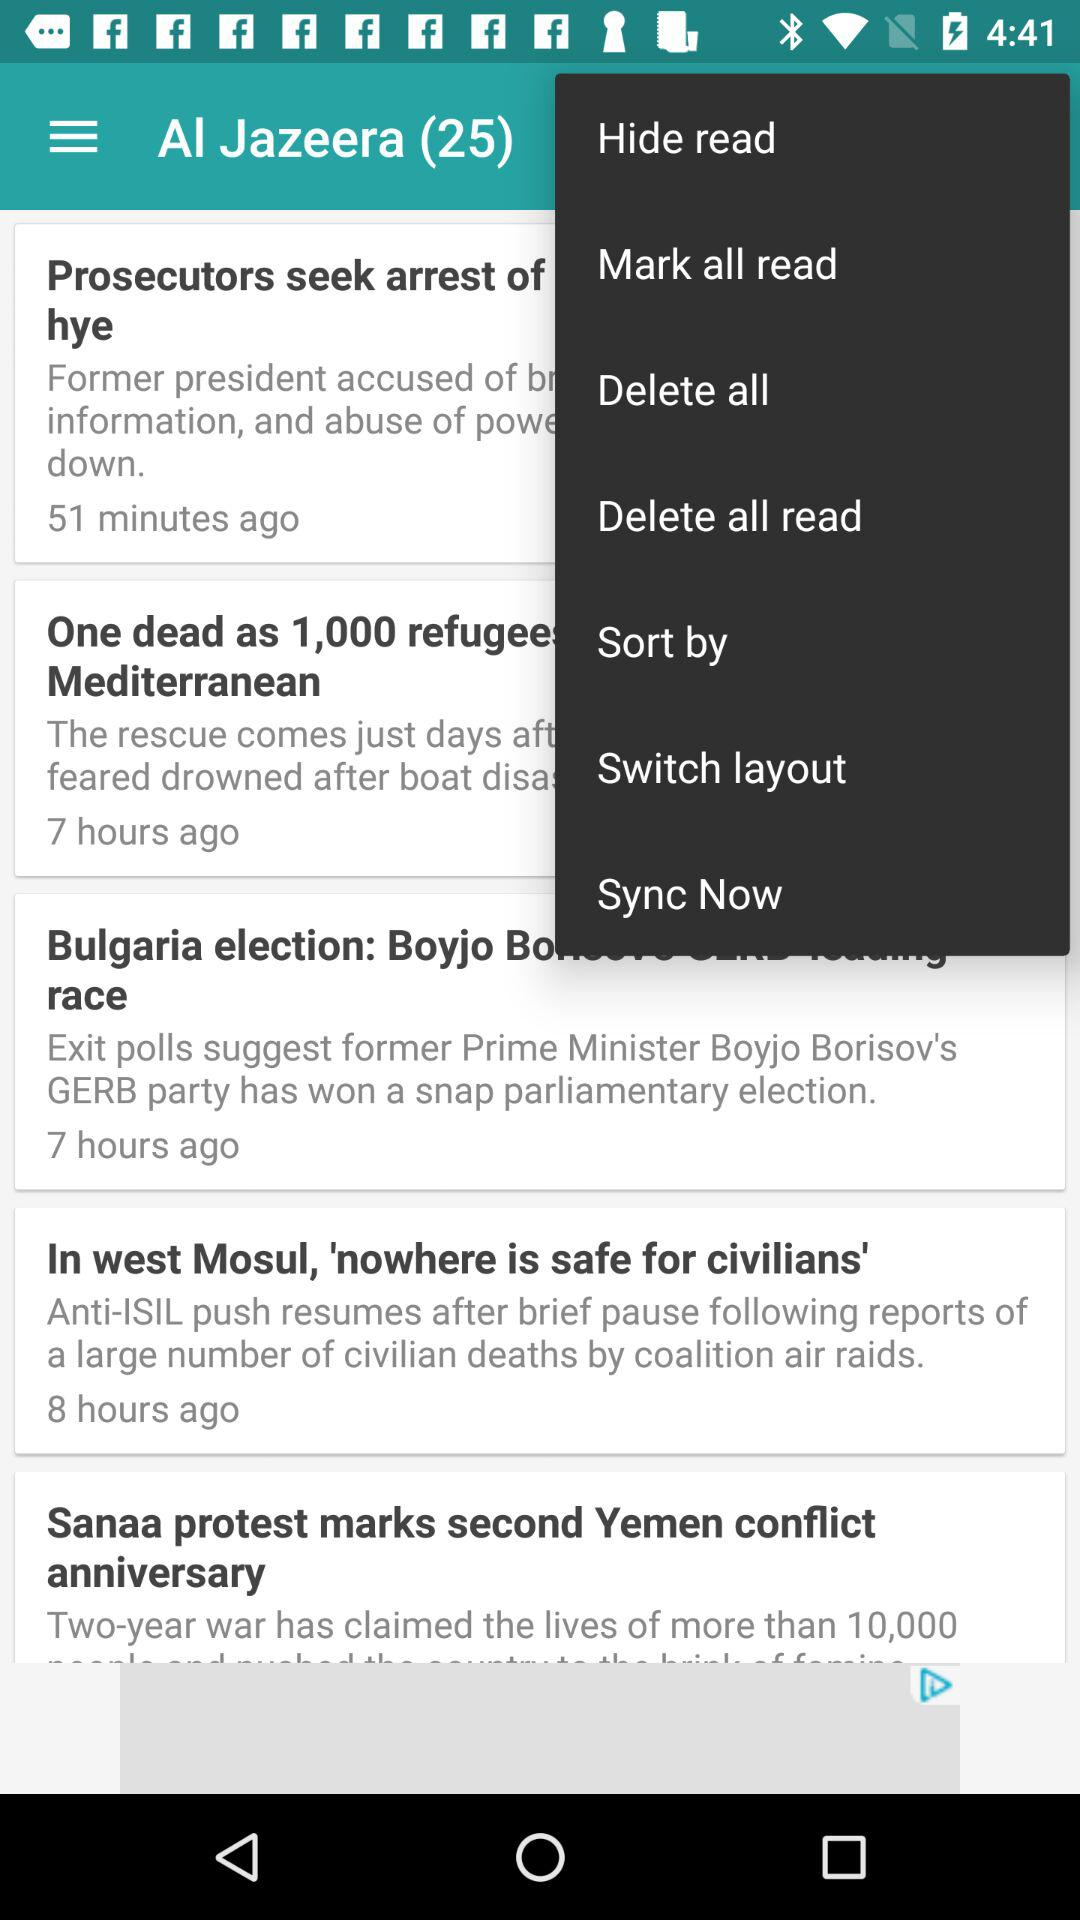Which option is selected in the drop-down menu?
When the provided information is insufficient, respond with <no answer>. <no answer> 